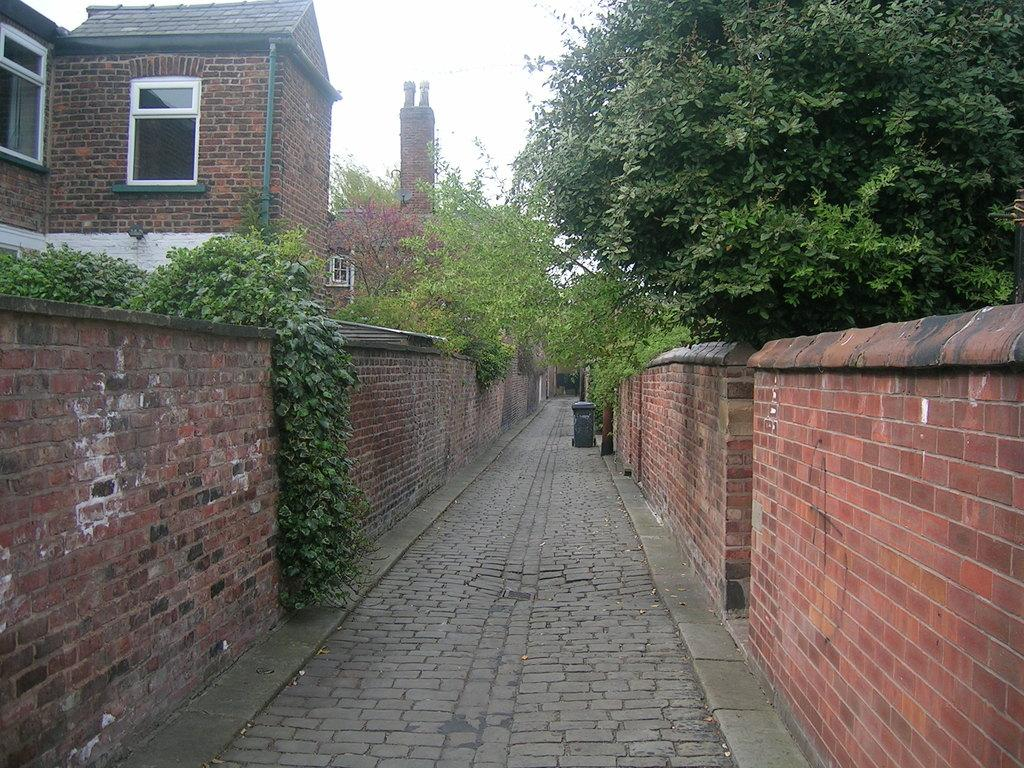What type of structures can be seen in the image? There are buildings in the image. What other natural elements are present in the image? There are trees in the image. What object is used for waste disposal in the image? There is a dustbin in the image. What type of cakes are being observed in the image? There are no cakes present in the image. What type of instrument is being played in the image? There is no instrument present in the image. 